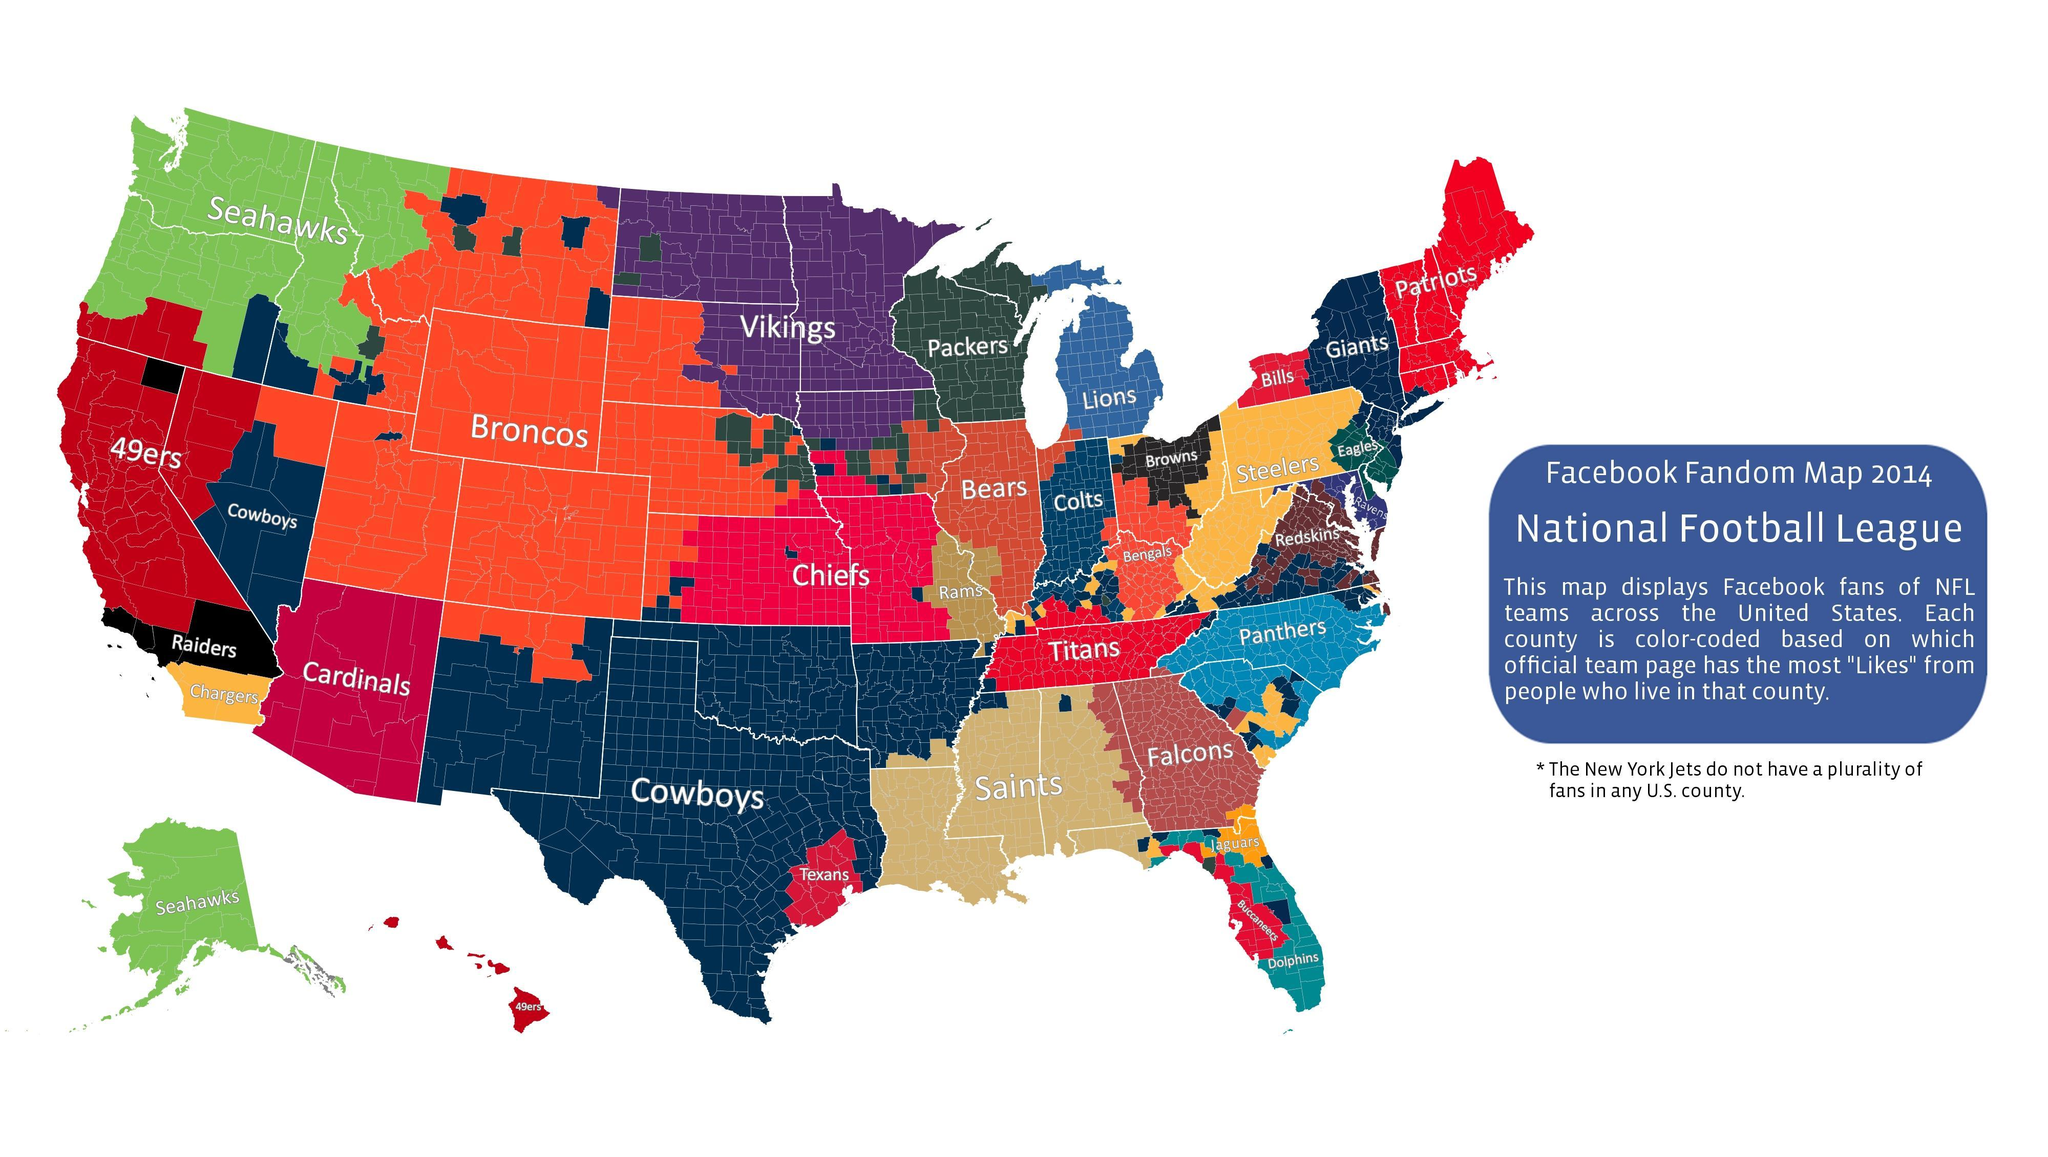Which team has the most number of FB likes ?
Answer the question with a short phrase. Cowboys Which team gets Facebook likes from Hawaii? 49ers Patriots are liked most in how many counties 6 WHich team has most number of FB likes in Tennessee Titans Which team gets Facebook likes from Alaska? Seahawks 